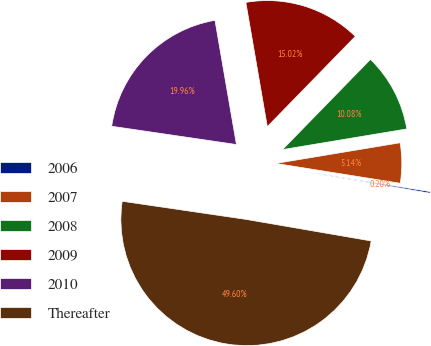Convert chart to OTSL. <chart><loc_0><loc_0><loc_500><loc_500><pie_chart><fcel>2006<fcel>2007<fcel>2008<fcel>2009<fcel>2010<fcel>Thereafter<nl><fcel>0.2%<fcel>5.14%<fcel>10.08%<fcel>15.02%<fcel>19.96%<fcel>49.6%<nl></chart> 